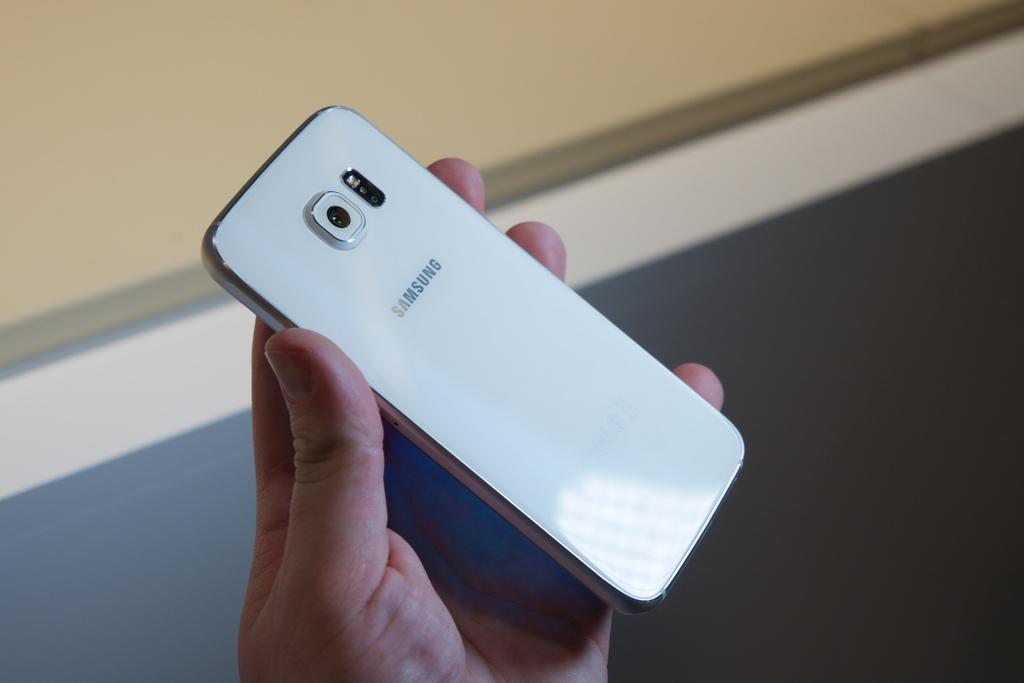Provide a one-sentence caption for the provided image. A hand holding up a white Samsung cell phone. 